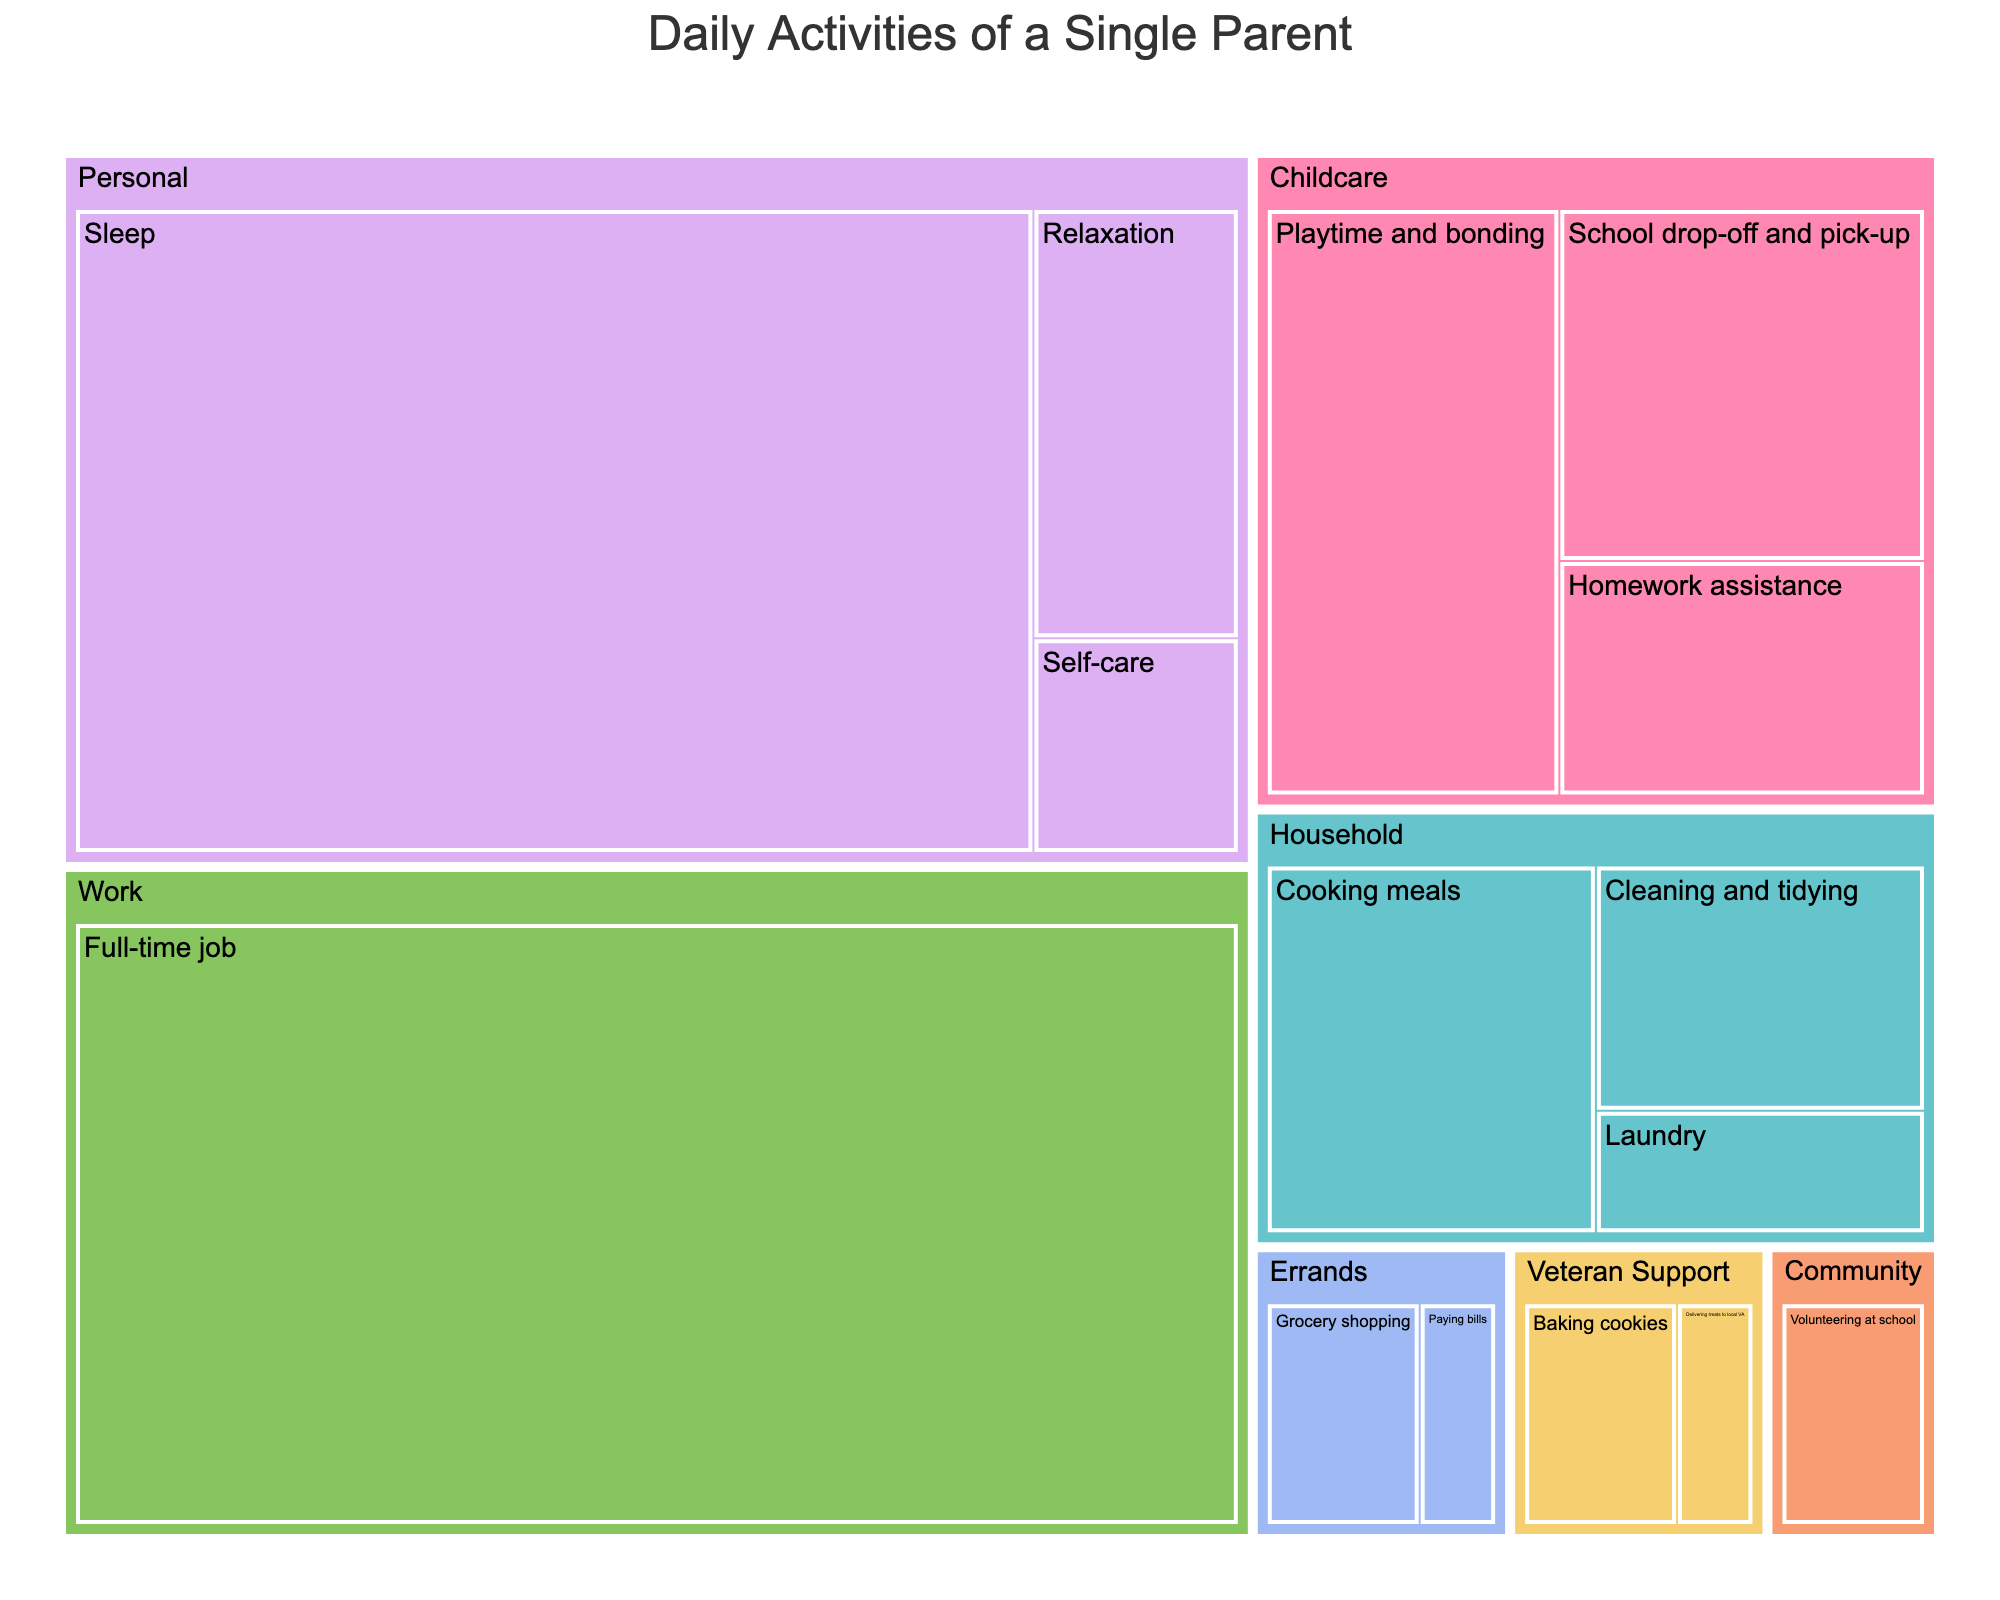What is the title of the treemap? Look at the top of the treemap where the title is usually displayed.
Answer: Daily Activities of a Single Parent How many hours are spent on 'Personal' activities in total? Sum up the time allocated to each subcategory under 'Personal' which includes Sleep (7 hours), Self-care (0.5 hours), and Relaxation (1 hour). So, 7 + 0.5 + 1 = 8.5 hours.
Answer: 8.5 hours Which subcategory within 'Childcare' takes the most time? Look at the size of the blocks under the 'Childcare' category. The largest block will represent the subcategory taking the most time.
Answer: Playtime and bonding If you combine time spent on 'Cooking meals' and 'Cleaning and tidying', how much time is allocated in total? Add the hours for 'Cooking meals' (1.5) and 'Cleaning and tidying' (1). So, 1.5 + 1 = 2.5 hours.
Answer: 2.5 hours Which category has the smallest allocation of time, and how much time is it? Identify the category with the smallest block and read off the time allocation from the label. The smallest block is likely within Veteran Support, as it shows categories baking cookies (0.5 hours) and delivering treats (0.25 hours), summed as 0.75 hours.
Answer: Veteran Support, 0.75 hours What is the average time spent on 'Errands' per subcategory? There are 2 subcategories under 'Errands': Grocery shopping (0.5 hours) and Paying bills (0.25 hours). Sum these times (0.5 + 0.25 = 0.75 hours), then divide by 2 subcategories. So, 0.75 / 2 = 0.375 hours.
Answer: 0.375 hours Are there more hours spent on 'Volunteering at school' or 'Delivering treats to local VA’? Compare the hours allocated to 'Volunteering at school' (0.5) and 'Delivering treats to local VA' (0.25).
Answer: Volunteering at school Which category takes the largest portion of a single parent’s daily routine? Look for the category with the largest overall block size, which is 'Work' with 8 hours.
Answer: Work How much more time is spent on 'Childcare' compared to 'Household' activities? Sum the time for 'Childcare' subcategories (1.5 + 1 + 2 = 4.5 hours) and 'Household' (1.5 + 1 + 0.5 = 3 hours). Then find the difference: 4.5 - 3 = 1.5 hours.
Answer: 1.5 hours What fraction of the day is spent on 'Self-care' relative to the total daily activities? 'Self-care' takes 0.5 hours. The total time (sum of all activities) is: 8 + 1.5 + 1 + 2 + 1.5 + 1 + 0.5 + 7 + 0.5 + 1 + 0.5 + 0.25 + 0.5 + 0.25 + 0.5 = 25.5 hours. The fraction is 0.5 / 25.5.
Answer: 1/51 